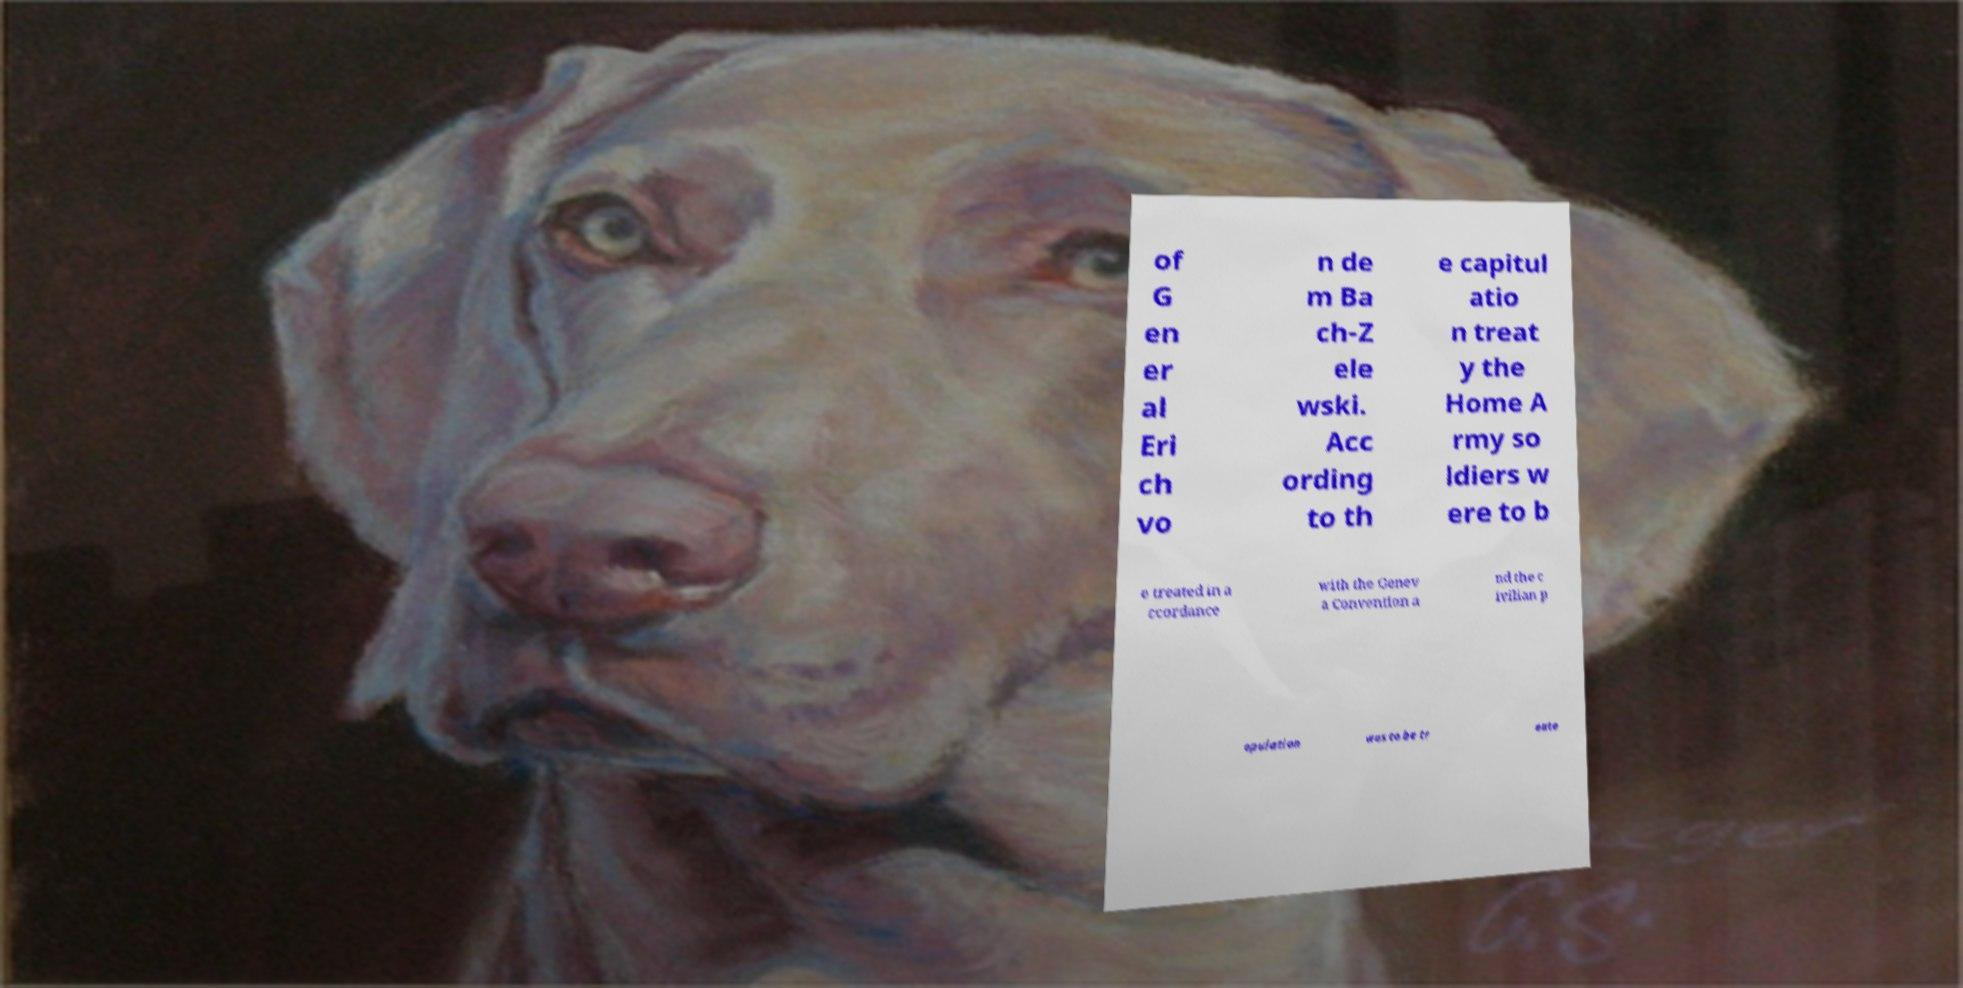Can you read and provide the text displayed in the image?This photo seems to have some interesting text. Can you extract and type it out for me? of G en er al Eri ch vo n de m Ba ch-Z ele wski. Acc ording to th e capitul atio n treat y the Home A rmy so ldiers w ere to b e treated in a ccordance with the Genev a Convention a nd the c ivilian p opulation was to be tr eate 